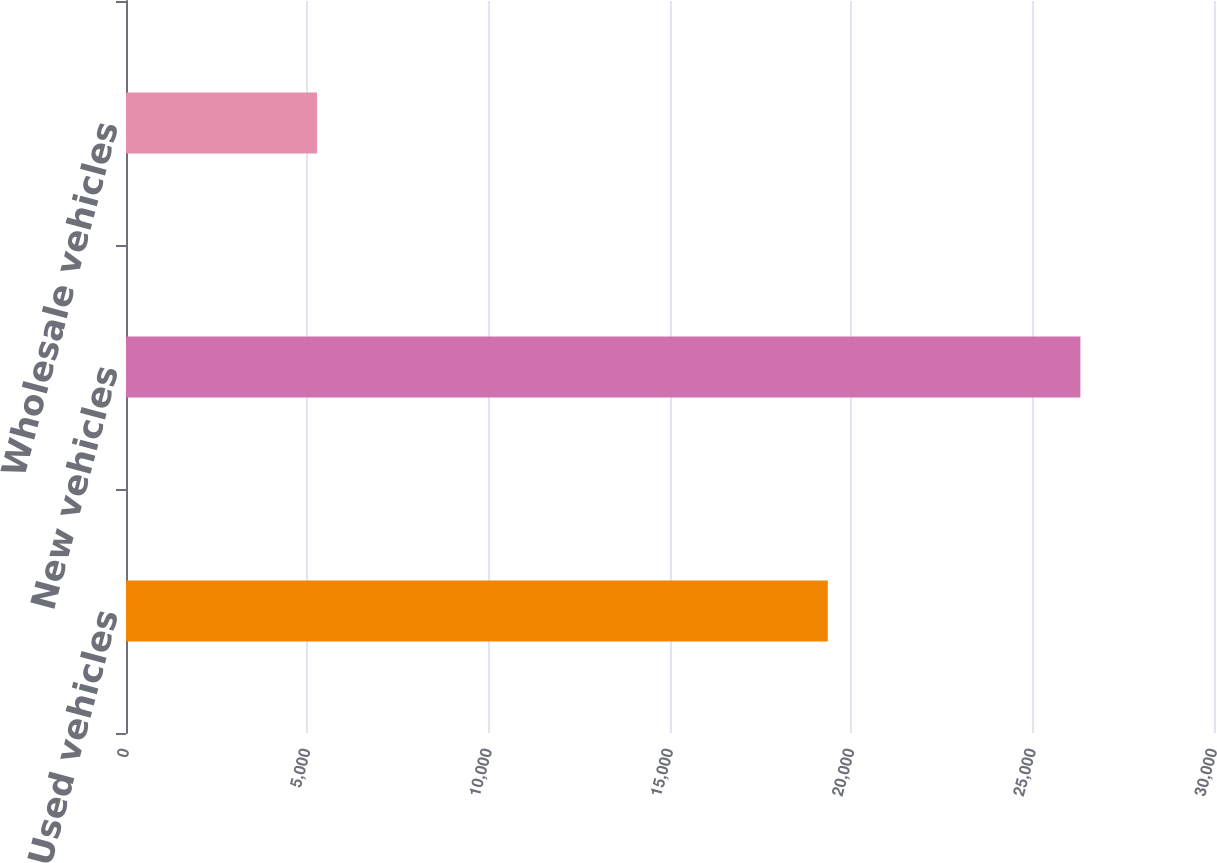Convert chart to OTSL. <chart><loc_0><loc_0><loc_500><loc_500><bar_chart><fcel>Used vehicles<fcel>New vehicles<fcel>Wholesale vehicles<nl><fcel>19351<fcel>26316<fcel>5268<nl></chart> 